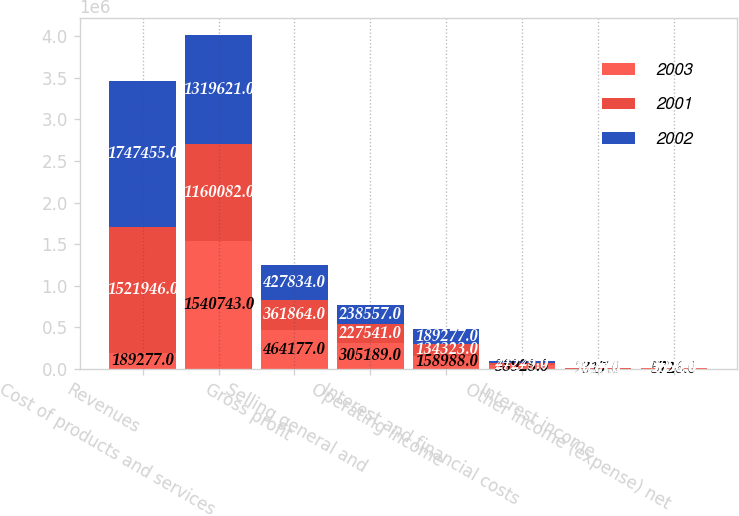Convert chart. <chart><loc_0><loc_0><loc_500><loc_500><stacked_bar_chart><ecel><fcel>Revenues<fcel>Cost of products and services<fcel>Gross profit<fcel>Selling general and<fcel>Operating income<fcel>Interest and financial costs<fcel>Interest income<fcel>Other income (expense) net<nl><fcel>2003<fcel>189277<fcel>1.54074e+06<fcel>464177<fcel>305189<fcel>158988<fcel>38928<fcel>2317<fcel>5726<nl><fcel>2001<fcel>1.52195e+06<fcel>1.16008e+06<fcel>361864<fcel>227541<fcel>134323<fcel>27279<fcel>2638<fcel>3656<nl><fcel>2002<fcel>1.74746e+06<fcel>1.31962e+06<fcel>427834<fcel>238557<fcel>189277<fcel>24929<fcel>1775<fcel>1894<nl></chart> 